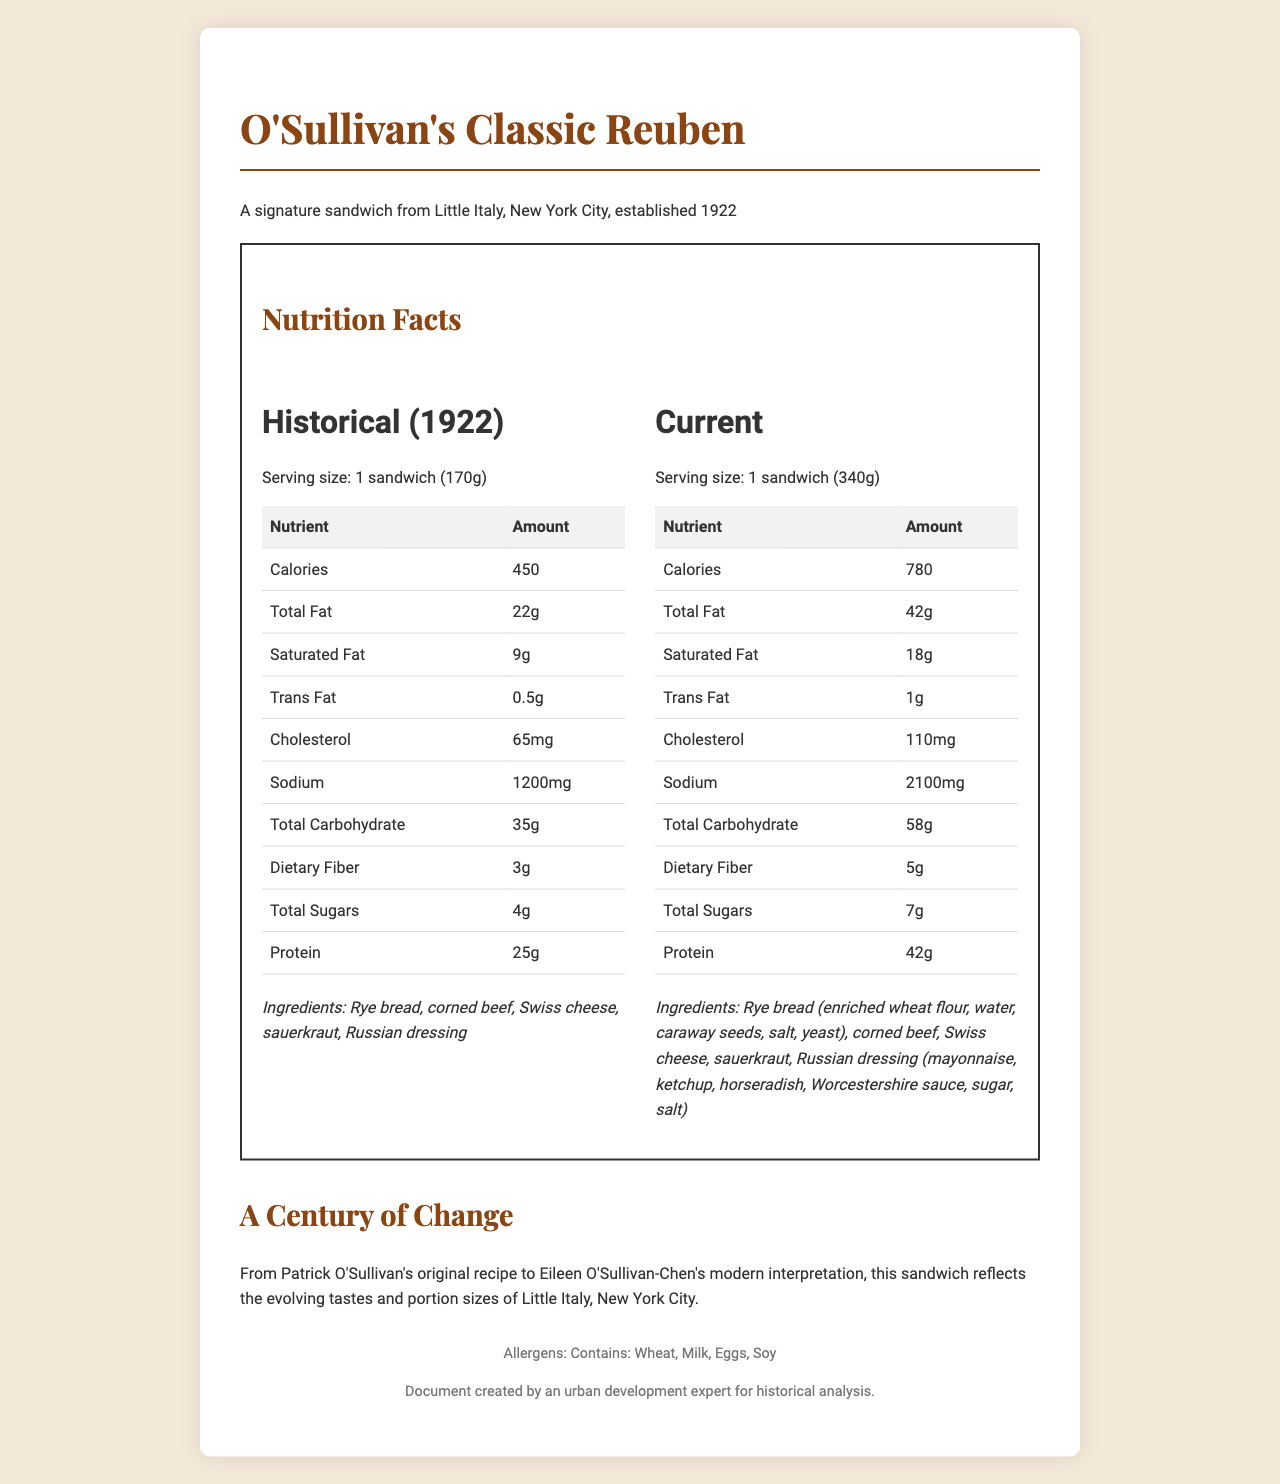How many calories are in the current version of the sandwich? The document lists the number of calories in the current version of the sandwich as 780.
Answer: 780 How many grams of fat are in the historical version of the sandwich? The document shows that the total fat in the historical version of the sandwich is 22 grams.
Answer: 22g What is the serving size of the current sandwich? The document states that the serving size of the current sandwich is 1 sandwich (340g).
Answer: 1 sandwich (340g) What has changed in the ingredients of the sandwich over time? The ingredients in the current version are more detailed and include additional specifics such as enriched wheat flour in rye bread and more components in the Russian dressing.
Answer: Rye bread now includes enriched wheat flour, water, caraway seeds, salt, and yeast; Russian dressing now lists mayonnaise, ketchup, horseradish, Worcestershire sauce, sugar, and salt. Who is the current owner of O'Sullivan's Deli? The document indicates that the current owner is Eileen O'Sullivan-Chen.
Answer: Eileen O'Sullivan-Chen Which nutrient saw the greatest increase in amount from the historical to the current sandwich? A. Protein B. Total Fat C. Sodium D. Total Carbohydrate Sodium increased from 1200mg to 2100mg, which is the largest increase observed in the nutrients listed.
Answer: C What is the percentage of daily value for Iron in the current sandwich? A. 10% B. 15% C. 20% D. 25% The document shows that the current sandwich has 25% of the daily value for Iron.
Answer: D Does the sandwich contain any allergens? The document lists that the sandwich contains Wheat, Milk, Eggs, and Soy as allergens.
Answer: Yes Has the amount of dietary fiber increased or decreased over time? The dietary fiber has increased from 3g in the historical version to 5g in the current version.
Answer: Increased Summarize the main changes in the sandwich's nutritional profile over the last century. The document compares the historical and current nutritional facts of O'Sullivan's Classic Reuben, highlighting significant increases in portion size and nutritional content, along with more detailed ingredient lists.
Answer: The serving size of O'Sullivan's Classic Reuben has doubled from 170g to 340g. Consequently, most nutritional values have increased significantly, including calories, total fat, saturated fat, cholesterol, sodium, total carbohydrates, dietary fiber, total sugars, and protein. The ingredients have become more detailed and specific. The sandwich reflects evolving portion sizes and modern dietary trends. What is the total sugar content in the current version of the sandwich? The document shows that the total sugar content in the current version of the sandwich is 7 grams.
Answer: 7g Why did O'Sullivan's Deli change the ingredients in their Russian dressing? The document does not provide an explanation for why the ingredients in the Russian dressing have changed.
Answer: I don't know 